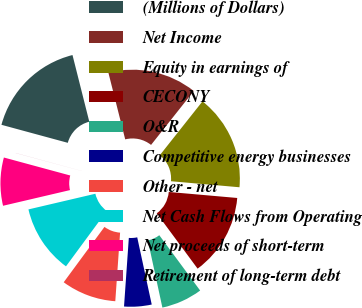Convert chart to OTSL. <chart><loc_0><loc_0><loc_500><loc_500><pie_chart><fcel>(Millions of Dollars)<fcel>Net Income<fcel>Equity in earnings of<fcel>CECONY<fcel>O&R<fcel>Competitive energy businesses<fcel>Other - net<fcel>Net Cash Flows from Operating<fcel>Net proceeds of short-term<fcel>Retirement of long-term debt<nl><fcel>16.85%<fcel>14.6%<fcel>15.73%<fcel>13.48%<fcel>6.74%<fcel>4.5%<fcel>8.99%<fcel>11.24%<fcel>7.87%<fcel>0.01%<nl></chart> 